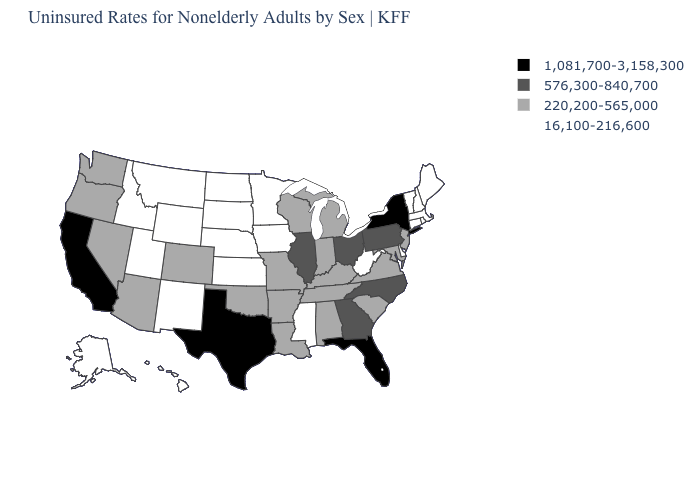Name the states that have a value in the range 1,081,700-3,158,300?
Answer briefly. California, Florida, New York, Texas. How many symbols are there in the legend?
Short answer required. 4. What is the value of Alabama?
Answer briefly. 220,200-565,000. Name the states that have a value in the range 16,100-216,600?
Keep it brief. Alaska, Connecticut, Delaware, Hawaii, Idaho, Iowa, Kansas, Maine, Massachusetts, Minnesota, Mississippi, Montana, Nebraska, New Hampshire, New Mexico, North Dakota, Rhode Island, South Dakota, Utah, Vermont, West Virginia, Wyoming. Does Utah have the lowest value in the USA?
Concise answer only. Yes. What is the highest value in the USA?
Concise answer only. 1,081,700-3,158,300. Does Idaho have a higher value than Georgia?
Short answer required. No. Name the states that have a value in the range 16,100-216,600?
Quick response, please. Alaska, Connecticut, Delaware, Hawaii, Idaho, Iowa, Kansas, Maine, Massachusetts, Minnesota, Mississippi, Montana, Nebraska, New Hampshire, New Mexico, North Dakota, Rhode Island, South Dakota, Utah, Vermont, West Virginia, Wyoming. What is the highest value in the USA?
Concise answer only. 1,081,700-3,158,300. Among the states that border Delaware , does Maryland have the lowest value?
Answer briefly. Yes. Does West Virginia have a lower value than Nebraska?
Be succinct. No. Does the first symbol in the legend represent the smallest category?
Write a very short answer. No. Name the states that have a value in the range 576,300-840,700?
Short answer required. Georgia, Illinois, North Carolina, Ohio, Pennsylvania. Which states hav the highest value in the MidWest?
Give a very brief answer. Illinois, Ohio. What is the lowest value in the West?
Quick response, please. 16,100-216,600. 